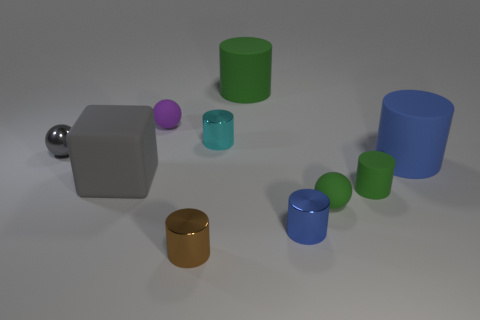How many green cylinders must be subtracted to get 1 green cylinders? 1 Subtract all metal balls. How many balls are left? 2 Subtract all spheres. How many objects are left? 7 Subtract 4 cylinders. How many cylinders are left? 2 Subtract all brown blocks. How many blue cylinders are left? 2 Subtract all cylinders. Subtract all metal things. How many objects are left? 0 Add 1 matte spheres. How many matte spheres are left? 3 Add 6 tiny cyan blocks. How many tiny cyan blocks exist? 6 Subtract all blue cylinders. How many cylinders are left? 4 Subtract 0 yellow balls. How many objects are left? 10 